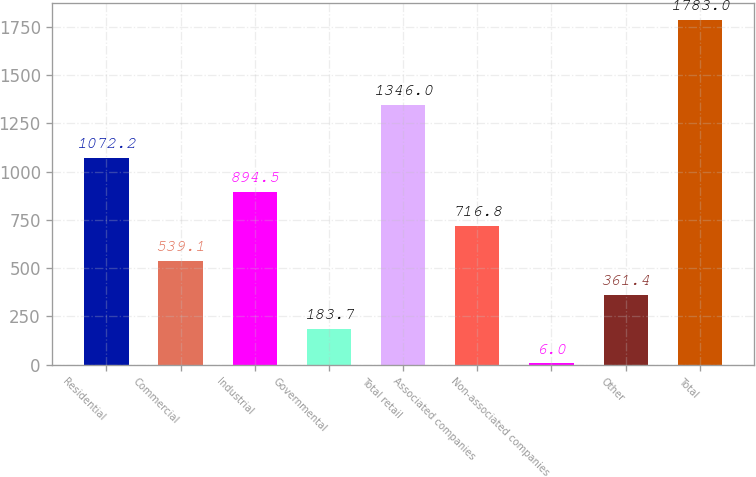<chart> <loc_0><loc_0><loc_500><loc_500><bar_chart><fcel>Residential<fcel>Commercial<fcel>Industrial<fcel>Governmental<fcel>Total retail<fcel>Associated companies<fcel>Non-associated companies<fcel>Other<fcel>Total<nl><fcel>1072.2<fcel>539.1<fcel>894.5<fcel>183.7<fcel>1346<fcel>716.8<fcel>6<fcel>361.4<fcel>1783<nl></chart> 